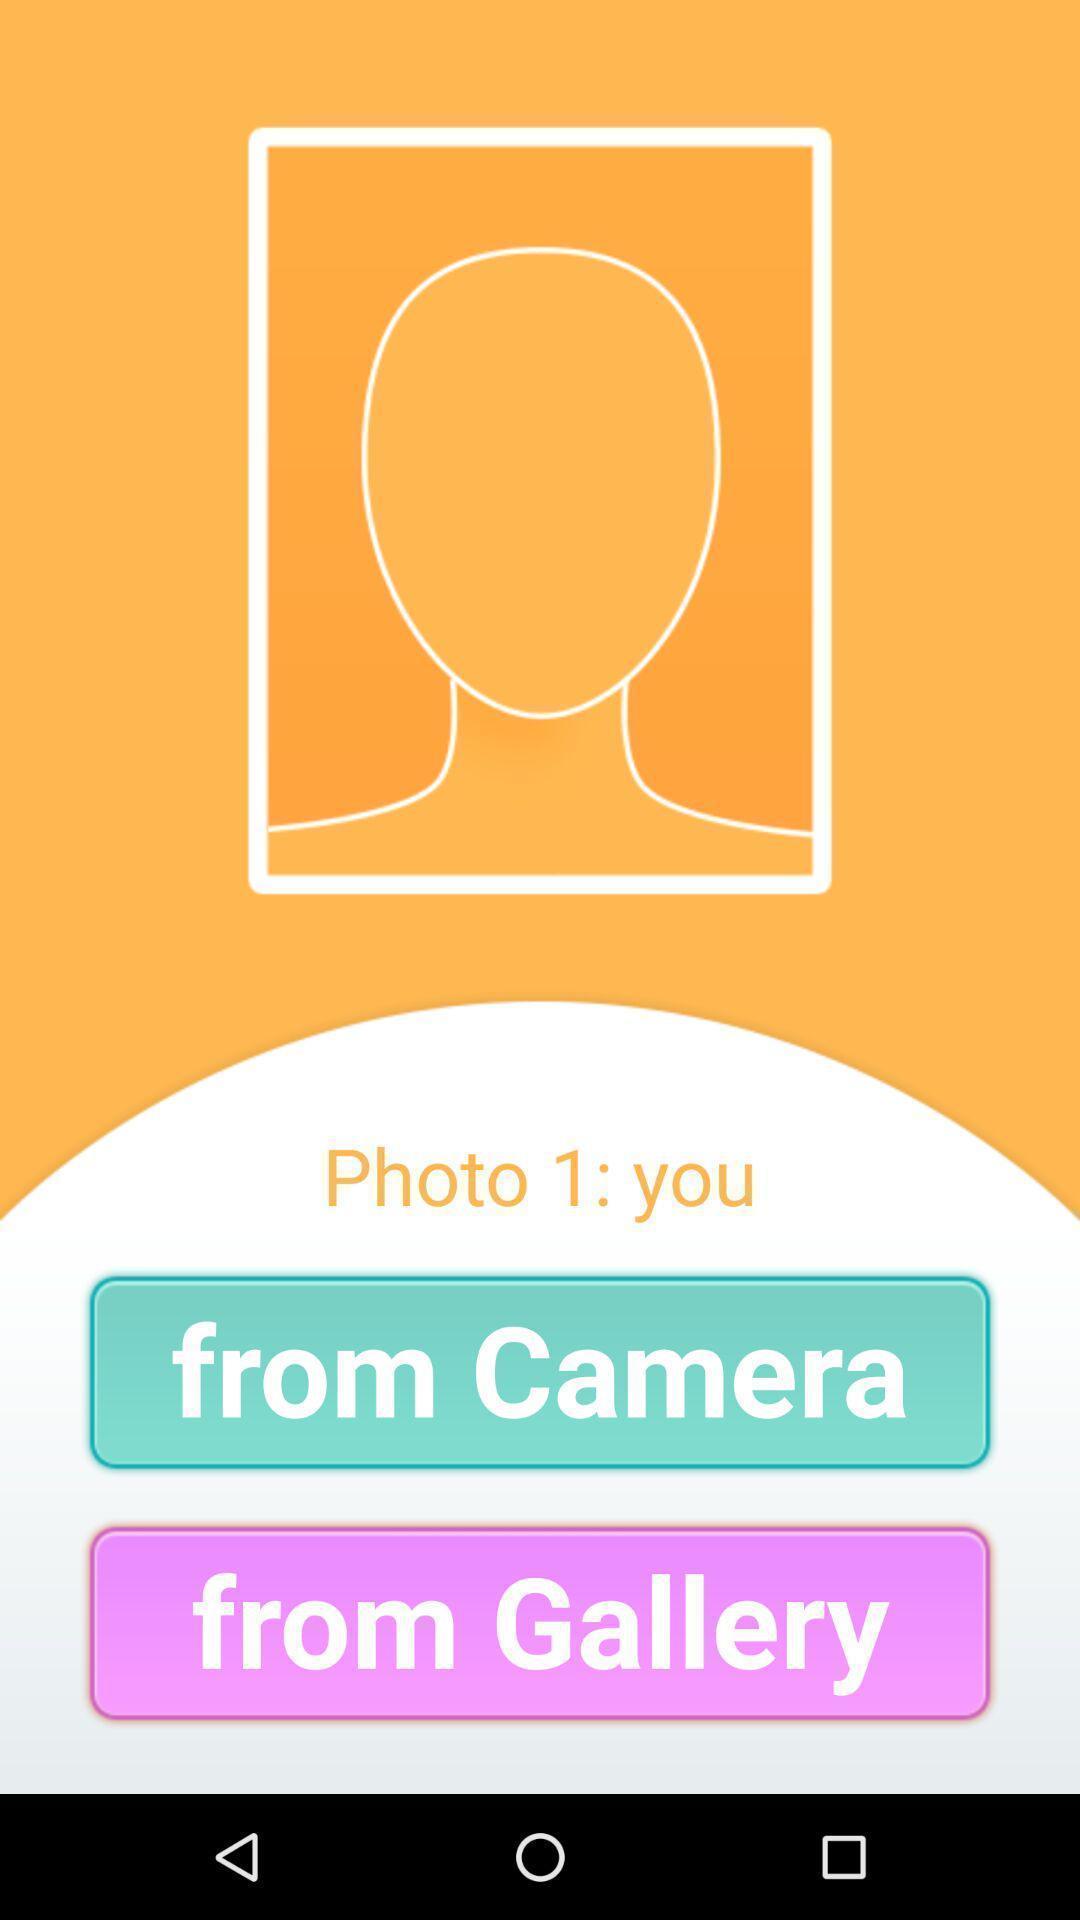What is the overall content of this screenshot? Select photo from camera or from gallery. 